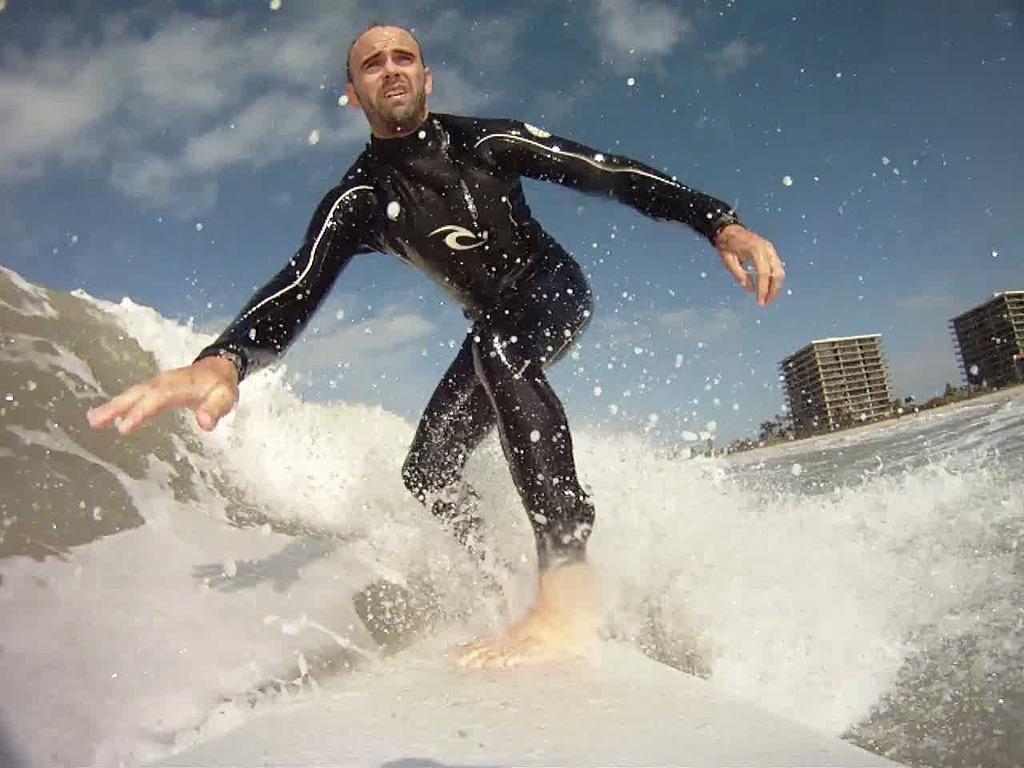In one or two sentences, can you explain what this image depicts? In this image I can see a person surfing in water, the person is wearing black dress, background I can see building in white color and sky in blue and white color. 